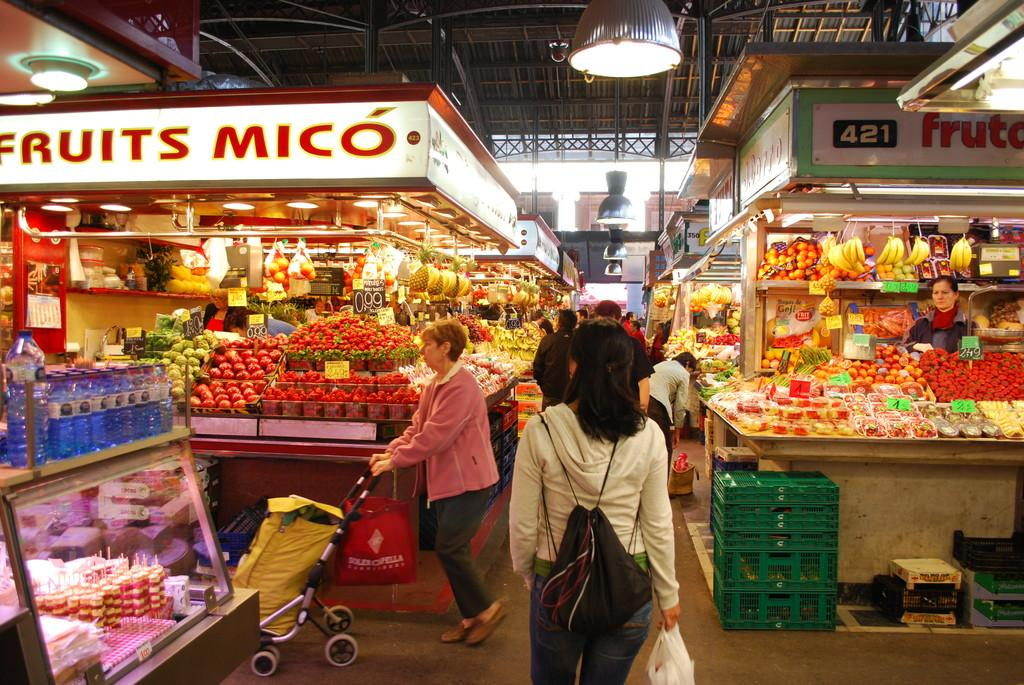Provide a one-sentence caption for the provided image. People shop in a store, with a section labelled Fruits Mico. 